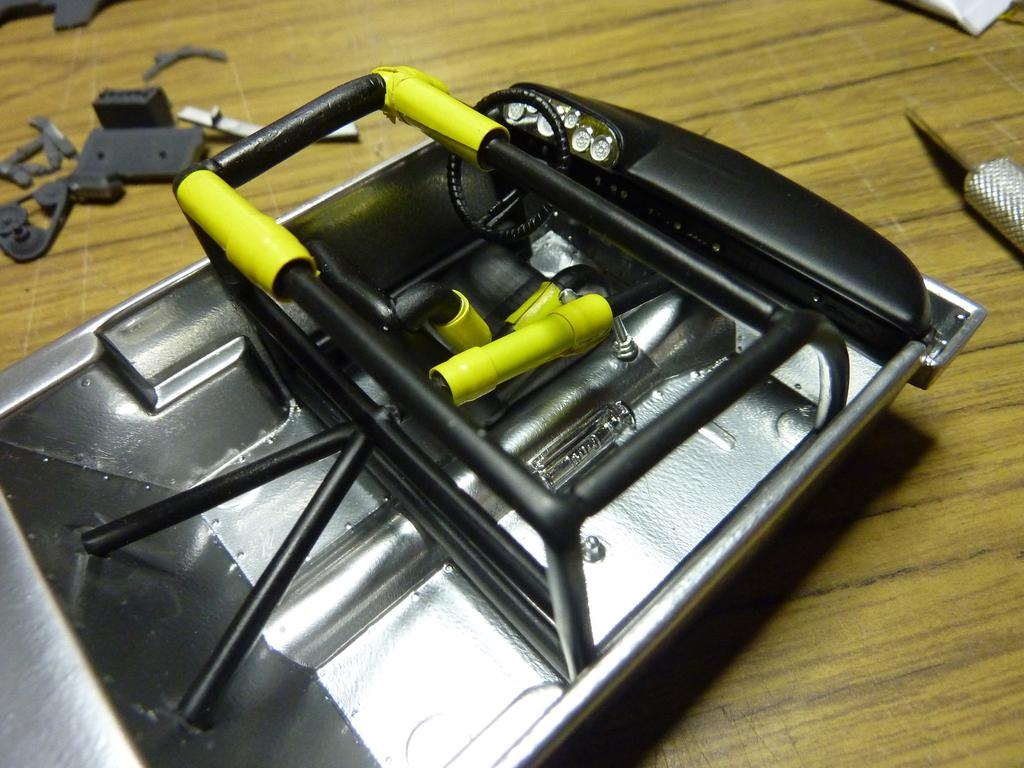What is placed on the wooden plank in the image? There is a toy vehicle on a wooden plank. What else can be seen on the wooden plank? There are nuts and vehicle parts on the wooden plank. Can you describe the object in the top right corner of the image? There is a tube in the top right corner of the image. What is the tendency of the house in the image? There is no house present in the image. What is the mass of the nuts on the wooden plank? The mass of the nuts cannot be determined from the image alone, as we do not have information about their size or weight. 